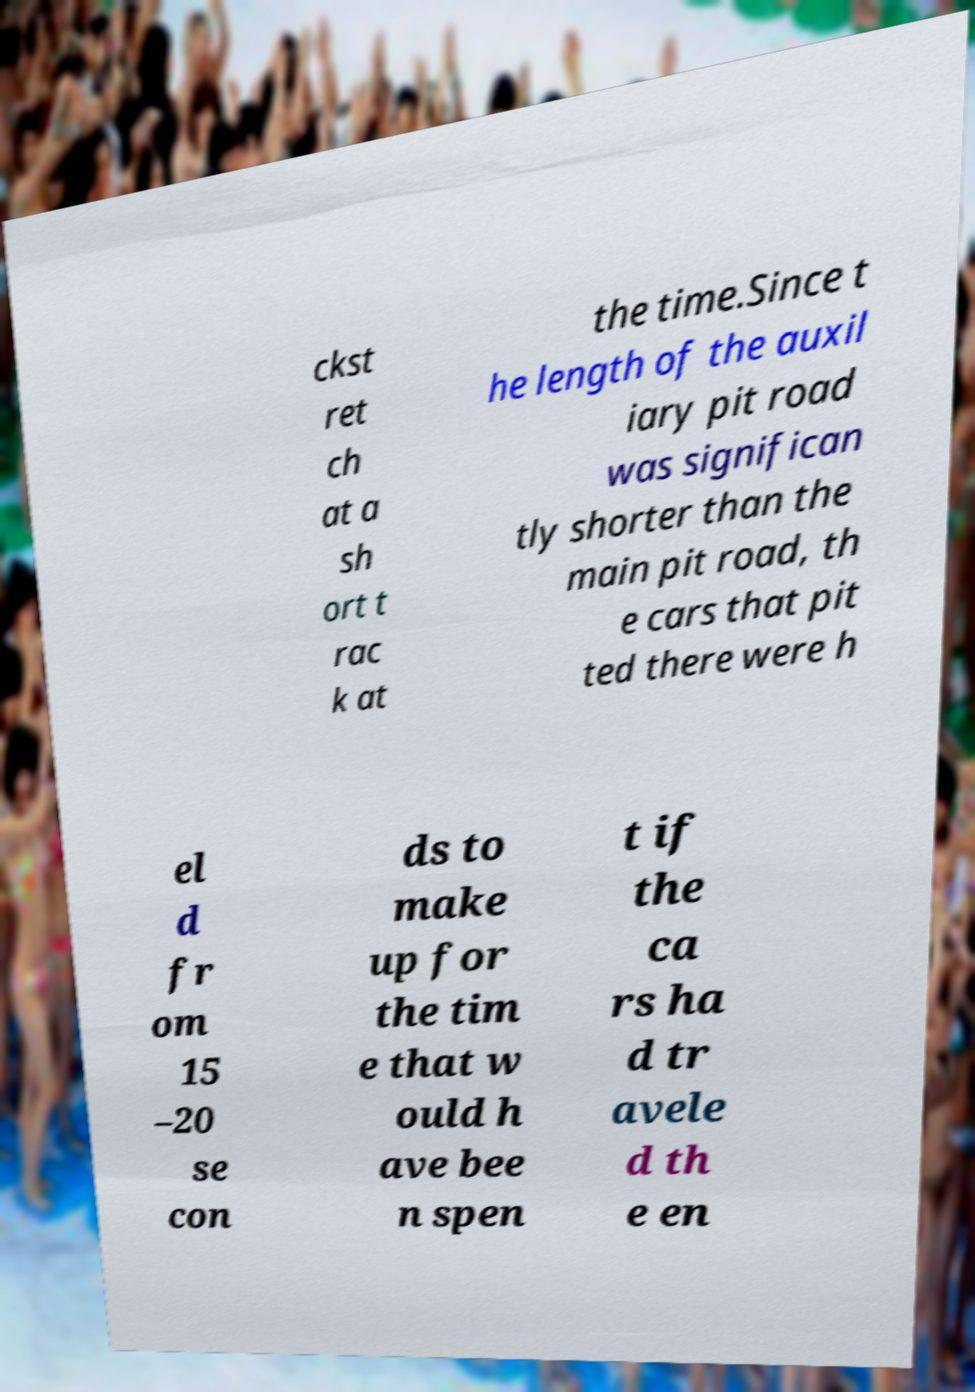There's text embedded in this image that I need extracted. Can you transcribe it verbatim? ckst ret ch at a sh ort t rac k at the time.Since t he length of the auxil iary pit road was significan tly shorter than the main pit road, th e cars that pit ted there were h el d fr om 15 –20 se con ds to make up for the tim e that w ould h ave bee n spen t if the ca rs ha d tr avele d th e en 